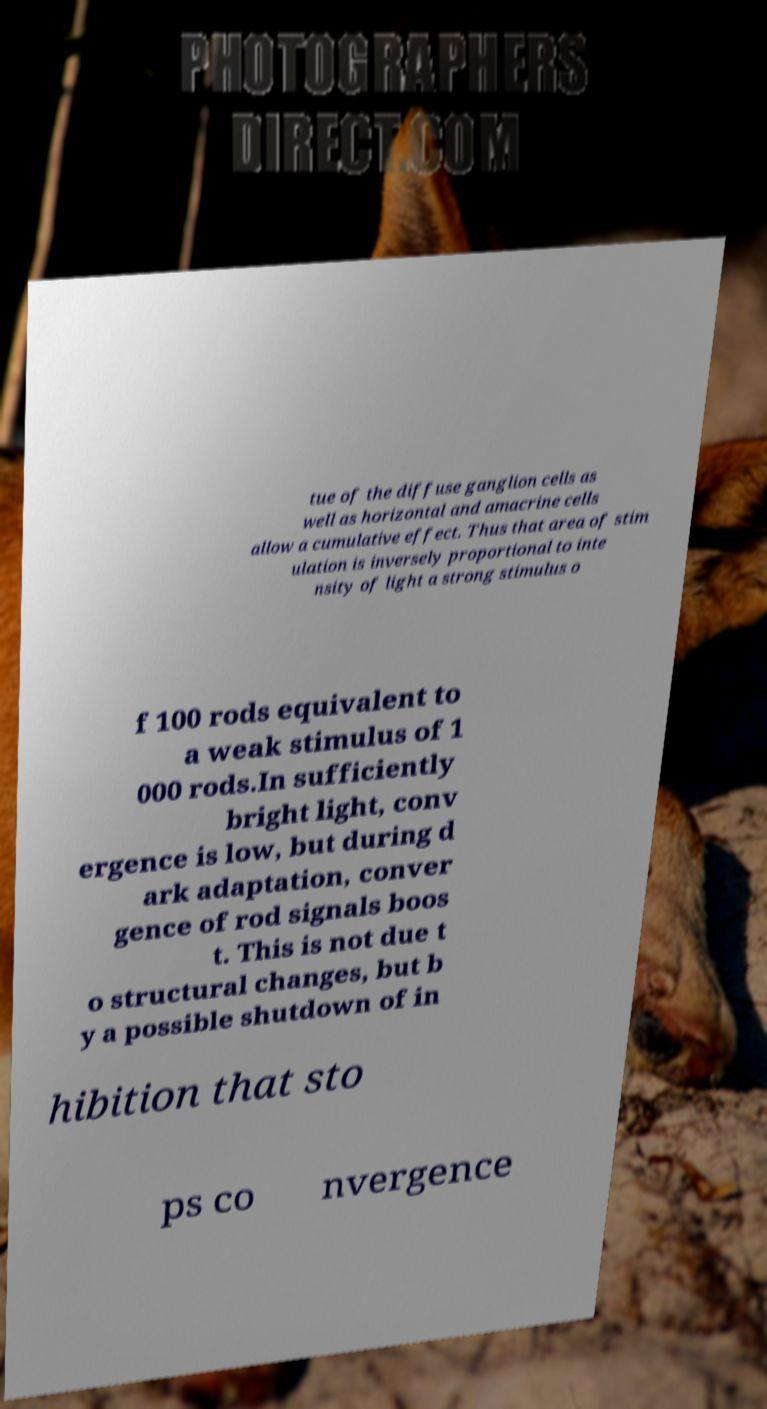There's text embedded in this image that I need extracted. Can you transcribe it verbatim? tue of the diffuse ganglion cells as well as horizontal and amacrine cells allow a cumulative effect. Thus that area of stim ulation is inversely proportional to inte nsity of light a strong stimulus o f 100 rods equivalent to a weak stimulus of 1 000 rods.In sufficiently bright light, conv ergence is low, but during d ark adaptation, conver gence of rod signals boos t. This is not due t o structural changes, but b y a possible shutdown of in hibition that sto ps co nvergence 